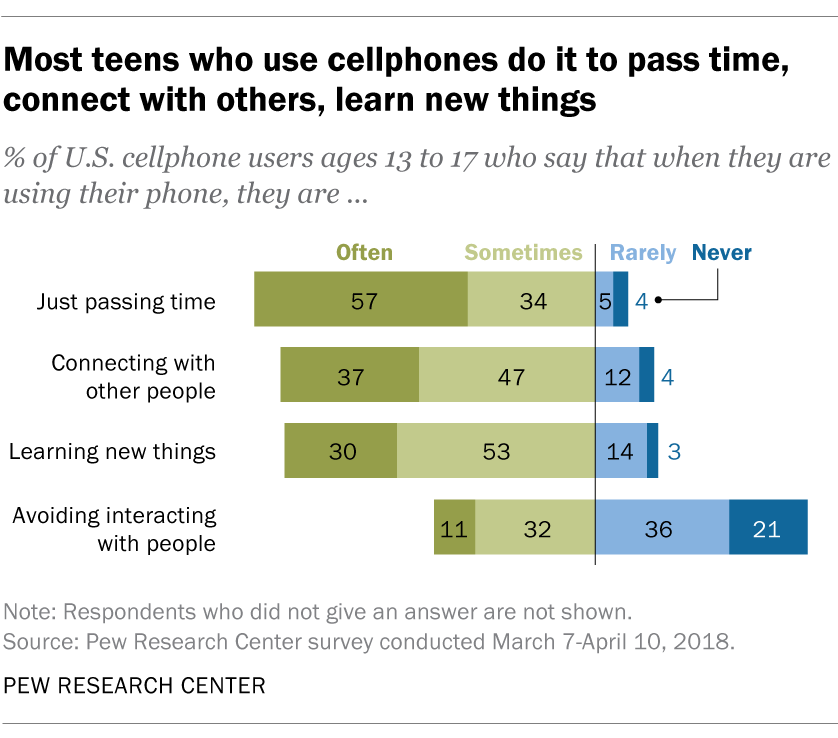Specify some key components in this picture. Based on the given information, the average of the light blue bars and the median of the light green bars are 33.375. The color of opinion bars is often light blue, and it is rare for them to be any other color. 